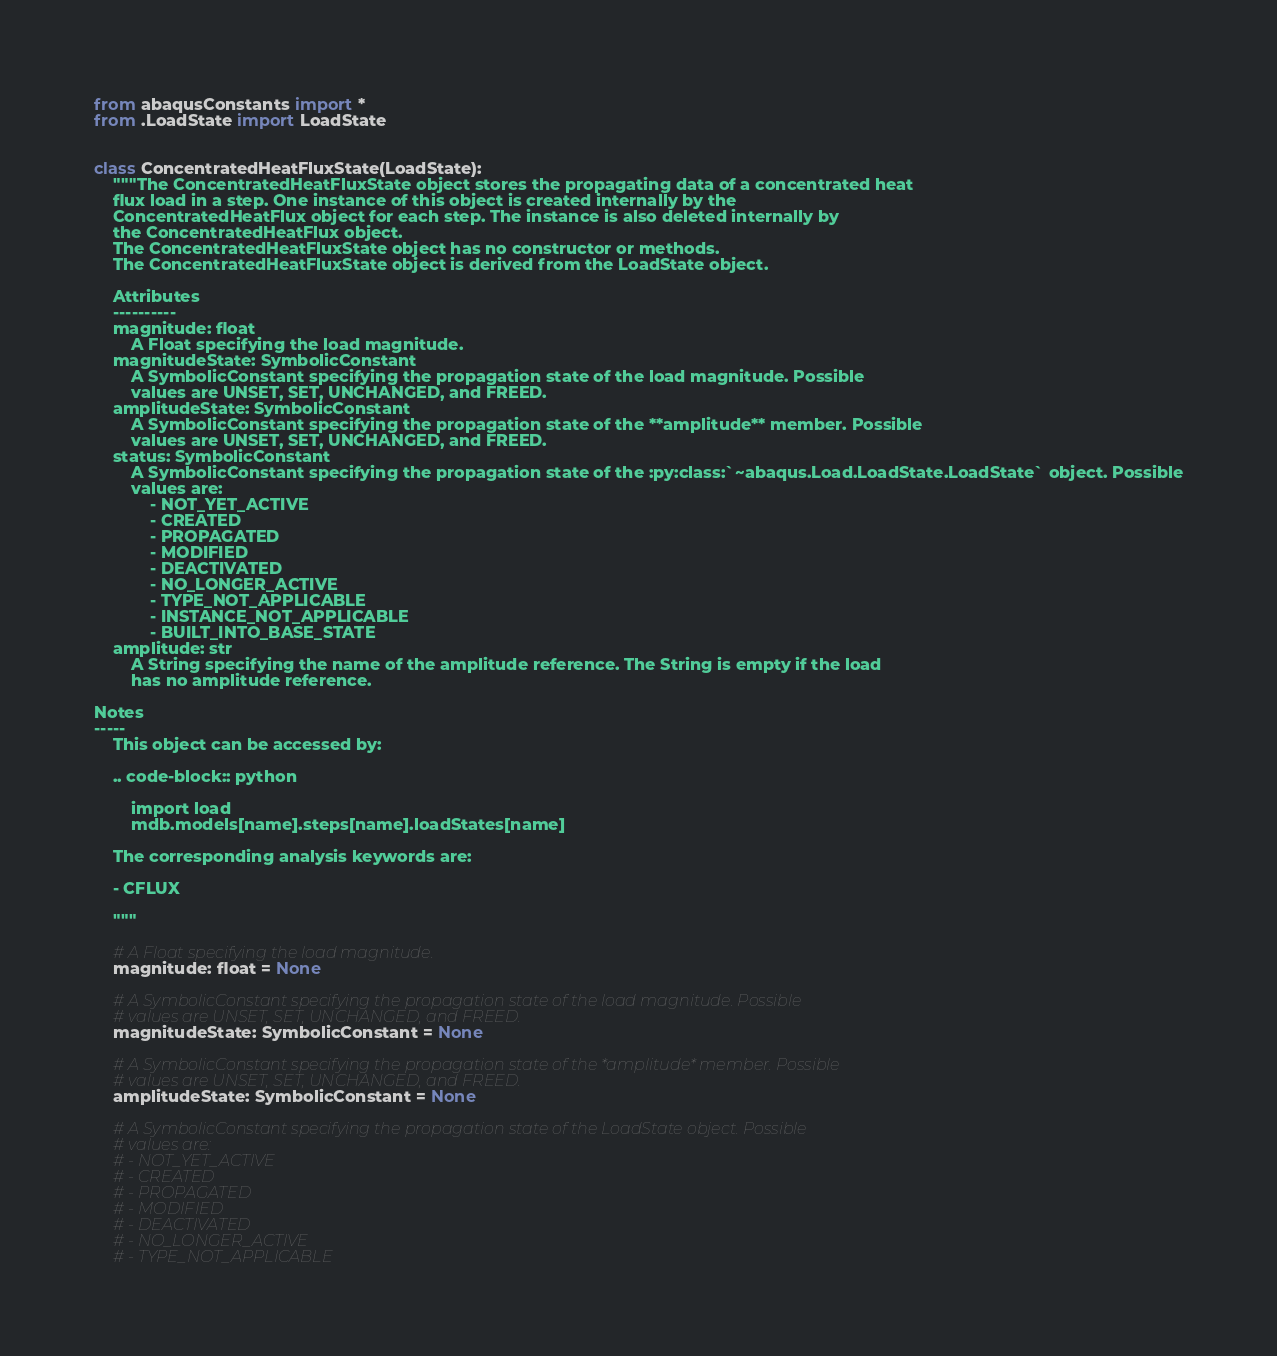Convert code to text. <code><loc_0><loc_0><loc_500><loc_500><_Python_>from abaqusConstants import *
from .LoadState import LoadState


class ConcentratedHeatFluxState(LoadState):
    """The ConcentratedHeatFluxState object stores the propagating data of a concentrated heat
    flux load in a step. One instance of this object is created internally by the 
    ConcentratedHeatFlux object for each step. The instance is also deleted internally by 
    the ConcentratedHeatFlux object. 
    The ConcentratedHeatFluxState object has no constructor or methods. 
    The ConcentratedHeatFluxState object is derived from the LoadState object. 

    Attributes
    ----------
    magnitude: float
        A Float specifying the load magnitude.
    magnitudeState: SymbolicConstant
        A SymbolicConstant specifying the propagation state of the load magnitude. Possible
        values are UNSET, SET, UNCHANGED, and FREED.
    amplitudeState: SymbolicConstant
        A SymbolicConstant specifying the propagation state of the **amplitude** member. Possible
        values are UNSET, SET, UNCHANGED, and FREED.
    status: SymbolicConstant
        A SymbolicConstant specifying the propagation state of the :py:class:`~abaqus.Load.LoadState.LoadState` object. Possible
        values are:
            - NOT_YET_ACTIVE
            - CREATED
            - PROPAGATED
            - MODIFIED
            - DEACTIVATED
            - NO_LONGER_ACTIVE
            - TYPE_NOT_APPLICABLE
            - INSTANCE_NOT_APPLICABLE
            - BUILT_INTO_BASE_STATE
    amplitude: str
        A String specifying the name of the amplitude reference. The String is empty if the load
        has no amplitude reference.

Notes
-----
    This object can be accessed by:
    
    .. code-block:: python
        
        import load
        mdb.models[name].steps[name].loadStates[name]

    The corresponding analysis keywords are:

    - CFLUX

    """

    # A Float specifying the load magnitude. 
    magnitude: float = None

    # A SymbolicConstant specifying the propagation state of the load magnitude. Possible 
    # values are UNSET, SET, UNCHANGED, and FREED. 
    magnitudeState: SymbolicConstant = None

    # A SymbolicConstant specifying the propagation state of the *amplitude* member. Possible 
    # values are UNSET, SET, UNCHANGED, and FREED. 
    amplitudeState: SymbolicConstant = None

    # A SymbolicConstant specifying the propagation state of the LoadState object. Possible 
    # values are: 
    # - NOT_YET_ACTIVE 
    # - CREATED 
    # - PROPAGATED 
    # - MODIFIED 
    # - DEACTIVATED 
    # - NO_LONGER_ACTIVE 
    # - TYPE_NOT_APPLICABLE </code> 